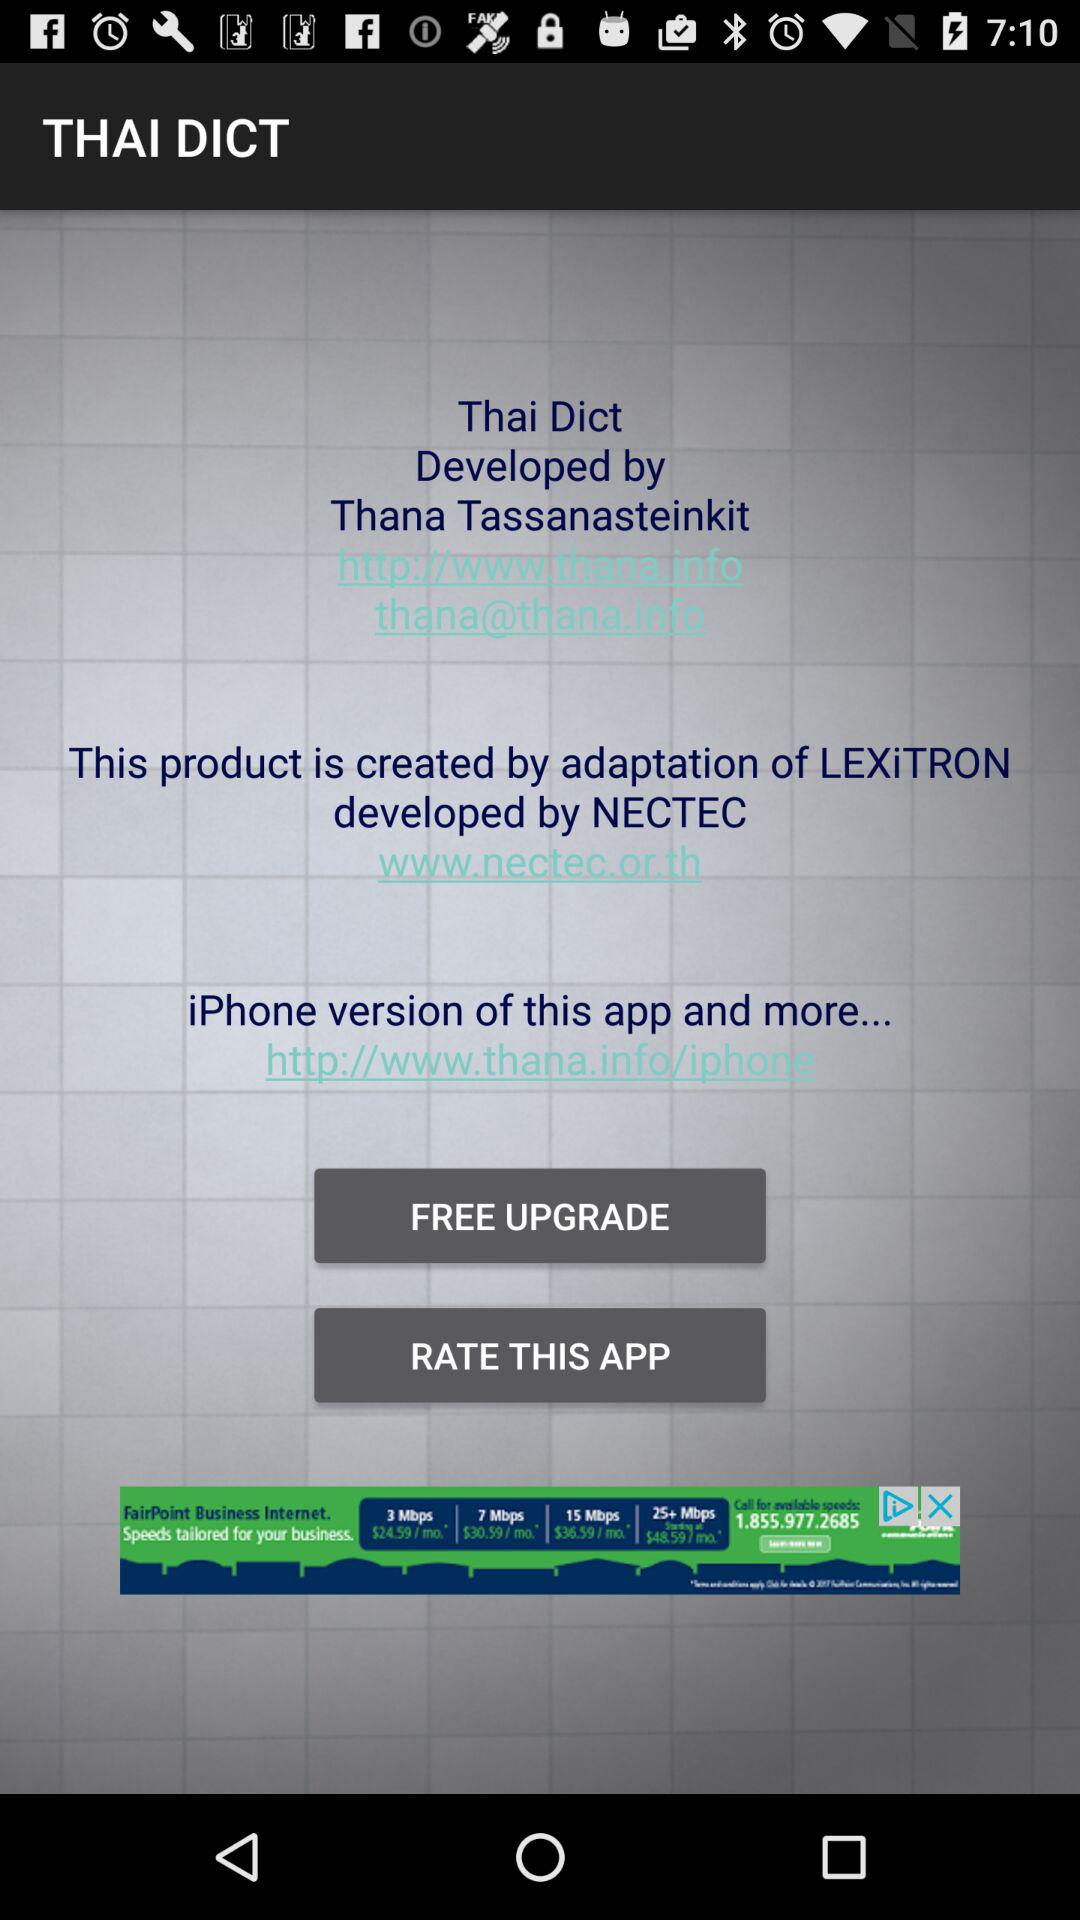What is the URL for the iPhone version? The URL is "http://www.thana.info/iphone". 